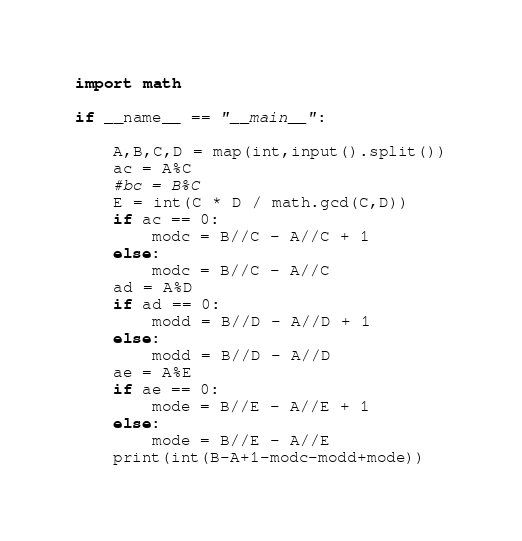Convert code to text. <code><loc_0><loc_0><loc_500><loc_500><_Python_>import math

if __name__ == "__main__":

    A,B,C,D = map(int,input().split())
    ac = A%C
    #bc = B%C
    E = int(C * D / math.gcd(C,D))
    if ac == 0:
        modc = B//C - A//C + 1
    else:
        modc = B//C - A//C
    ad = A%D
    if ad == 0:
        modd = B//D - A//D + 1
    else:
        modd = B//D - A//D
    ae = A%E
    if ae == 0:
        mode = B//E - A//E + 1
    else:
        mode = B//E - A//E
    print(int(B-A+1-modc-modd+mode))
</code> 